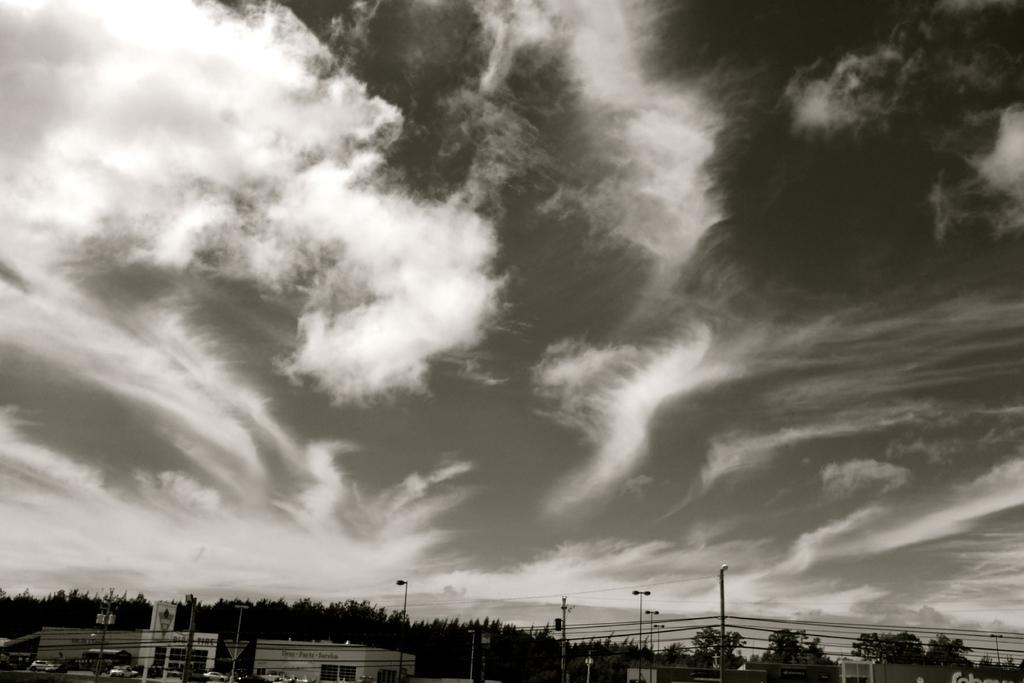Can you describe this image briefly? In this picture we can observe trees. There are some cars on the road. We can observe some poles and wires. In the background and there is a sky with some clouds. 